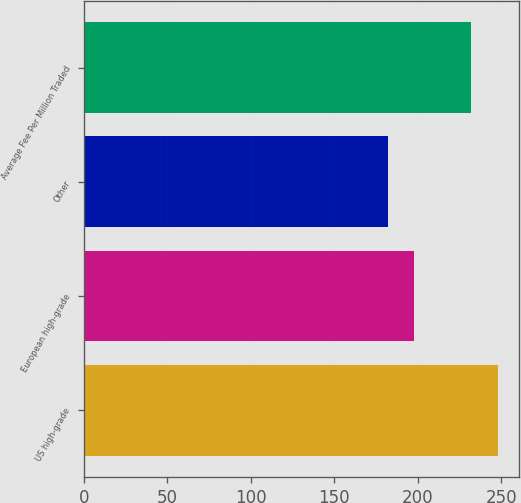Convert chart. <chart><loc_0><loc_0><loc_500><loc_500><bar_chart><fcel>US high-grade<fcel>European high-grade<fcel>Other<fcel>Average Fee Per Million Traded<nl><fcel>248<fcel>198<fcel>182<fcel>231.6<nl></chart> 